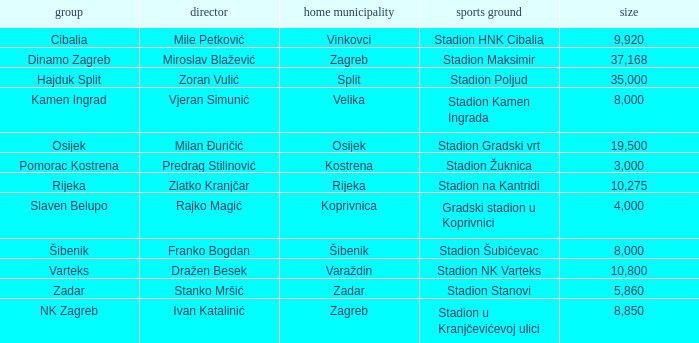What is the stadium of the NK Zagreb? Stadion u Kranjčevićevoj ulici. 